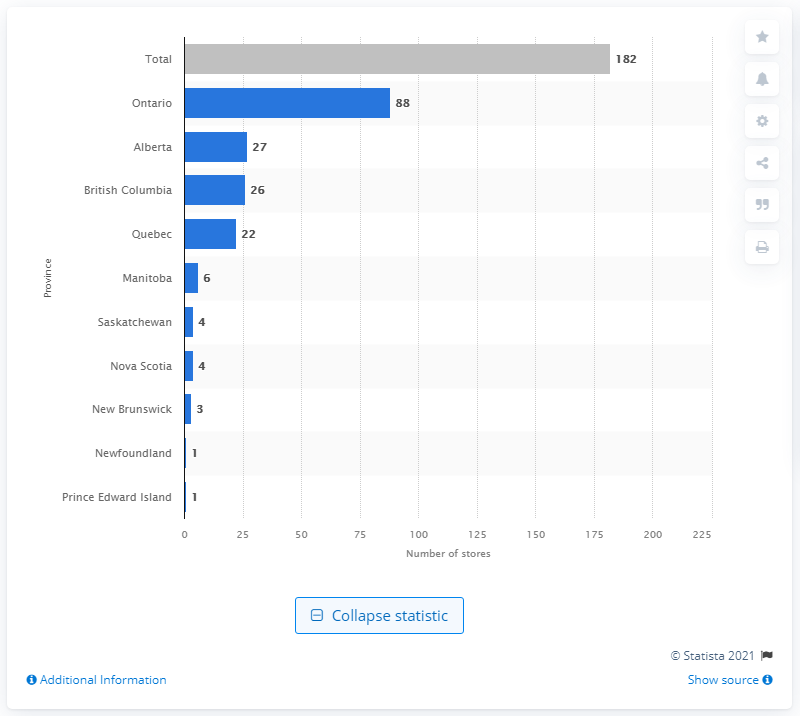Draw attention to some important aspects in this diagram. As of 2020, there were 182 Home Depot stores in Canada. As of 2020, there were 88 Home Depot stores located in the province of Ontario. 